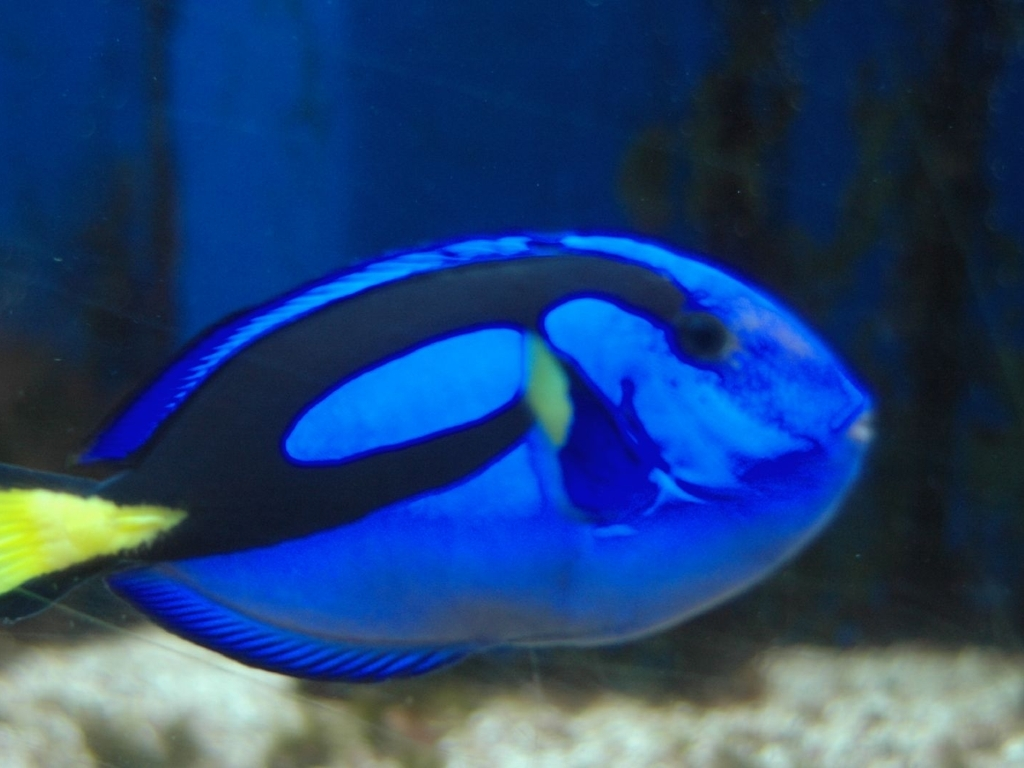Could you tell me about the behavior of the creature in the image? Blue tangs are known to be relatively peaceful and are often seen in schools grazing on algae during the day. They exhibit a synchronized swimming pattern for defense, and at night, they find crevices in the reef to rest safely. Are they important to their ecosystem? Absolutely, blue tangs are vital for maintaining the health of coral reefs. They help control algae growth, which if left unchecked, can overgrow and suffocate corals. Their role as grazers keeps the reef clean and allows for better light and nutrient penetration, which benefits the whole marine community. 